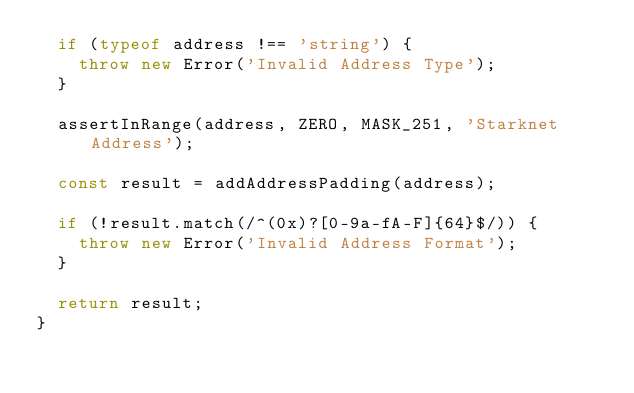Convert code to text. <code><loc_0><loc_0><loc_500><loc_500><_TypeScript_>  if (typeof address !== 'string') {
    throw new Error('Invalid Address Type');
  }

  assertInRange(address, ZERO, MASK_251, 'Starknet Address');

  const result = addAddressPadding(address);

  if (!result.match(/^(0x)?[0-9a-fA-F]{64}$/)) {
    throw new Error('Invalid Address Format');
  }

  return result;
}
</code> 